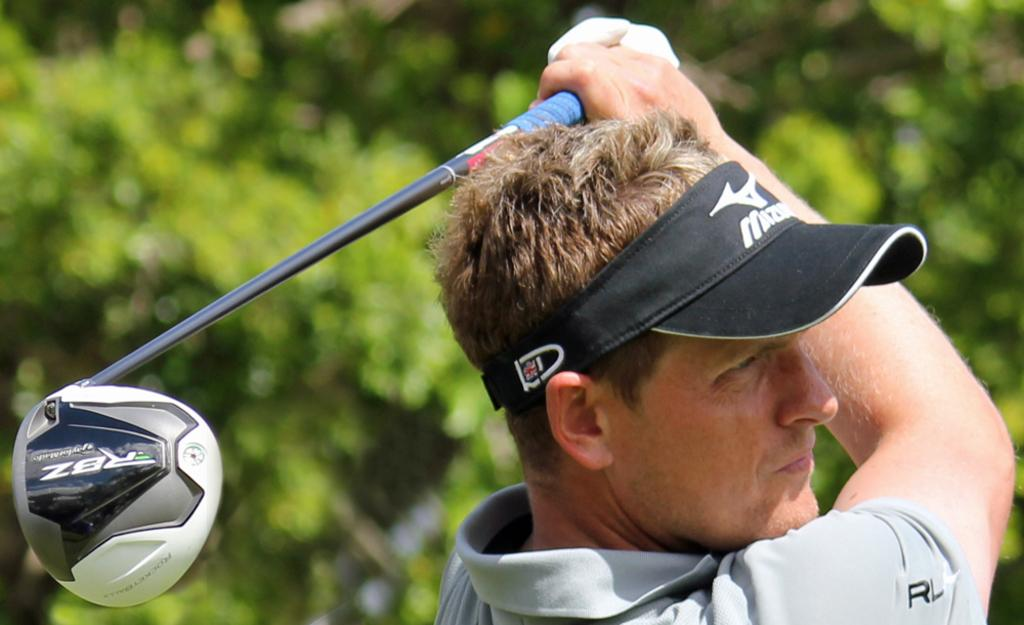Who is present in the image? There is a man in the image. What is the man holding in the image? The man is holding a golf stick. What type of headwear is the man wearing? The man is wearing a cap. What can be seen in the background of the image? Trees are visible in the image. What type of soda is the man drinking in the image? There is no soda present in the image; the man is holding a golf stick and wearing a cap. 